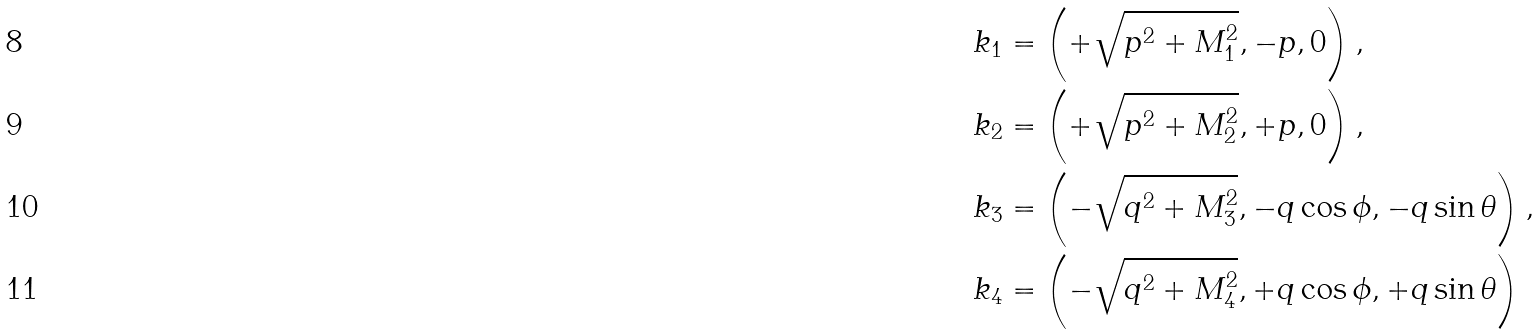Convert formula to latex. <formula><loc_0><loc_0><loc_500><loc_500>k _ { 1 } & = \left ( + \sqrt { p ^ { 2 } + M _ { 1 } ^ { 2 } } , - p , 0 \right ) , \\ k _ { 2 } & = \left ( + \sqrt { p ^ { 2 } + M _ { 2 } ^ { 2 } } , + p , 0 \right ) , \\ k _ { 3 } & = \left ( - \sqrt { q ^ { 2 } + M _ { 3 } ^ { 2 } } , - q \cos \phi , - q \sin \theta \right ) , \\ k _ { 4 } & = \left ( - \sqrt { q ^ { 2 } + M _ { 4 } ^ { 2 } } , + q \cos \phi , + q \sin \theta \right )</formula> 